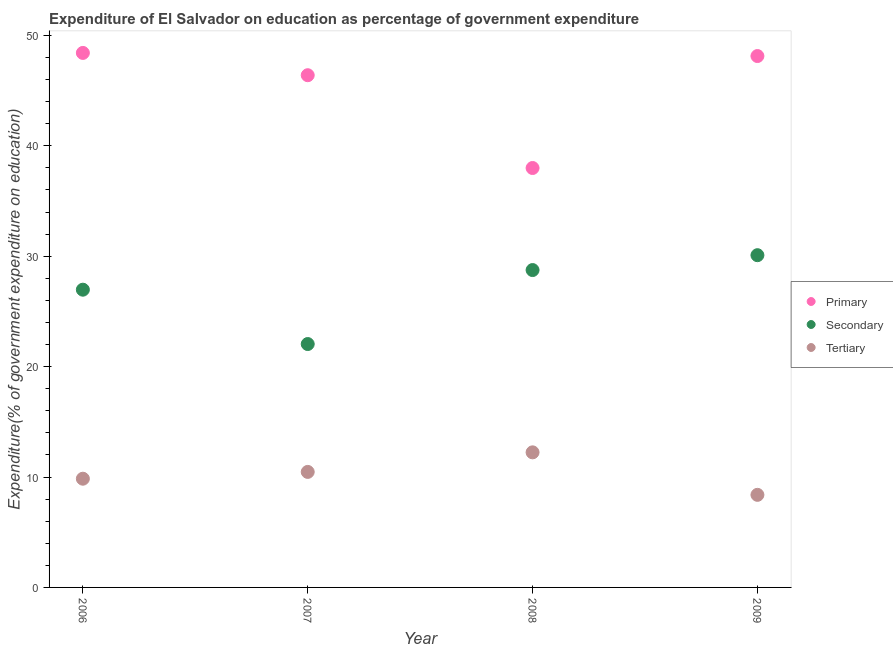How many different coloured dotlines are there?
Offer a very short reply. 3. Is the number of dotlines equal to the number of legend labels?
Your answer should be compact. Yes. What is the expenditure on primary education in 2008?
Offer a terse response. 37.99. Across all years, what is the maximum expenditure on tertiary education?
Ensure brevity in your answer.  12.24. Across all years, what is the minimum expenditure on tertiary education?
Offer a very short reply. 8.39. In which year was the expenditure on secondary education maximum?
Your answer should be compact. 2009. What is the total expenditure on secondary education in the graph?
Your response must be concise. 107.86. What is the difference between the expenditure on primary education in 2008 and that in 2009?
Provide a short and direct response. -10.14. What is the difference between the expenditure on secondary education in 2007 and the expenditure on tertiary education in 2008?
Offer a very short reply. 9.81. What is the average expenditure on tertiary education per year?
Give a very brief answer. 10.23. In the year 2007, what is the difference between the expenditure on tertiary education and expenditure on secondary education?
Keep it short and to the point. -11.58. In how many years, is the expenditure on tertiary education greater than 38 %?
Give a very brief answer. 0. What is the ratio of the expenditure on secondary education in 2007 to that in 2008?
Your answer should be very brief. 0.77. Is the expenditure on primary education in 2007 less than that in 2009?
Your response must be concise. Yes. Is the difference between the expenditure on tertiary education in 2007 and 2009 greater than the difference between the expenditure on primary education in 2007 and 2009?
Keep it short and to the point. Yes. What is the difference between the highest and the second highest expenditure on secondary education?
Provide a succinct answer. 1.35. What is the difference between the highest and the lowest expenditure on secondary education?
Ensure brevity in your answer.  8.05. In how many years, is the expenditure on tertiary education greater than the average expenditure on tertiary education taken over all years?
Your answer should be compact. 2. Is the expenditure on tertiary education strictly greater than the expenditure on primary education over the years?
Keep it short and to the point. No. Is the expenditure on tertiary education strictly less than the expenditure on secondary education over the years?
Keep it short and to the point. Yes. What is the difference between two consecutive major ticks on the Y-axis?
Your answer should be compact. 10. Does the graph contain grids?
Give a very brief answer. No. How many legend labels are there?
Your answer should be very brief. 3. How are the legend labels stacked?
Your answer should be compact. Vertical. What is the title of the graph?
Make the answer very short. Expenditure of El Salvador on education as percentage of government expenditure. What is the label or title of the X-axis?
Your answer should be very brief. Year. What is the label or title of the Y-axis?
Make the answer very short. Expenditure(% of government expenditure on education). What is the Expenditure(% of government expenditure on education) in Primary in 2006?
Your answer should be very brief. 48.42. What is the Expenditure(% of government expenditure on education) of Secondary in 2006?
Keep it short and to the point. 26.97. What is the Expenditure(% of government expenditure on education) in Tertiary in 2006?
Ensure brevity in your answer.  9.85. What is the Expenditure(% of government expenditure on education) of Primary in 2007?
Offer a terse response. 46.4. What is the Expenditure(% of government expenditure on education) of Secondary in 2007?
Provide a succinct answer. 22.05. What is the Expenditure(% of government expenditure on education) in Tertiary in 2007?
Your response must be concise. 10.46. What is the Expenditure(% of government expenditure on education) of Primary in 2008?
Provide a short and direct response. 37.99. What is the Expenditure(% of government expenditure on education) of Secondary in 2008?
Give a very brief answer. 28.75. What is the Expenditure(% of government expenditure on education) of Tertiary in 2008?
Your answer should be compact. 12.24. What is the Expenditure(% of government expenditure on education) in Primary in 2009?
Provide a short and direct response. 48.13. What is the Expenditure(% of government expenditure on education) in Secondary in 2009?
Provide a succinct answer. 30.09. What is the Expenditure(% of government expenditure on education) of Tertiary in 2009?
Ensure brevity in your answer.  8.39. Across all years, what is the maximum Expenditure(% of government expenditure on education) of Primary?
Give a very brief answer. 48.42. Across all years, what is the maximum Expenditure(% of government expenditure on education) in Secondary?
Offer a terse response. 30.09. Across all years, what is the maximum Expenditure(% of government expenditure on education) in Tertiary?
Your response must be concise. 12.24. Across all years, what is the minimum Expenditure(% of government expenditure on education) in Primary?
Keep it short and to the point. 37.99. Across all years, what is the minimum Expenditure(% of government expenditure on education) of Secondary?
Your answer should be compact. 22.05. Across all years, what is the minimum Expenditure(% of government expenditure on education) in Tertiary?
Keep it short and to the point. 8.39. What is the total Expenditure(% of government expenditure on education) of Primary in the graph?
Provide a succinct answer. 180.94. What is the total Expenditure(% of government expenditure on education) of Secondary in the graph?
Give a very brief answer. 107.86. What is the total Expenditure(% of government expenditure on education) in Tertiary in the graph?
Offer a terse response. 40.93. What is the difference between the Expenditure(% of government expenditure on education) in Primary in 2006 and that in 2007?
Offer a terse response. 2.02. What is the difference between the Expenditure(% of government expenditure on education) in Secondary in 2006 and that in 2007?
Provide a short and direct response. 4.92. What is the difference between the Expenditure(% of government expenditure on education) of Tertiary in 2006 and that in 2007?
Keep it short and to the point. -0.62. What is the difference between the Expenditure(% of government expenditure on education) in Primary in 2006 and that in 2008?
Offer a very short reply. 10.42. What is the difference between the Expenditure(% of government expenditure on education) of Secondary in 2006 and that in 2008?
Your answer should be compact. -1.78. What is the difference between the Expenditure(% of government expenditure on education) of Tertiary in 2006 and that in 2008?
Provide a succinct answer. -2.39. What is the difference between the Expenditure(% of government expenditure on education) in Primary in 2006 and that in 2009?
Offer a terse response. 0.28. What is the difference between the Expenditure(% of government expenditure on education) of Secondary in 2006 and that in 2009?
Your response must be concise. -3.13. What is the difference between the Expenditure(% of government expenditure on education) of Tertiary in 2006 and that in 2009?
Ensure brevity in your answer.  1.46. What is the difference between the Expenditure(% of government expenditure on education) in Primary in 2007 and that in 2008?
Your response must be concise. 8.41. What is the difference between the Expenditure(% of government expenditure on education) in Secondary in 2007 and that in 2008?
Your response must be concise. -6.7. What is the difference between the Expenditure(% of government expenditure on education) in Tertiary in 2007 and that in 2008?
Make the answer very short. -1.77. What is the difference between the Expenditure(% of government expenditure on education) in Primary in 2007 and that in 2009?
Your answer should be very brief. -1.74. What is the difference between the Expenditure(% of government expenditure on education) of Secondary in 2007 and that in 2009?
Make the answer very short. -8.05. What is the difference between the Expenditure(% of government expenditure on education) of Tertiary in 2007 and that in 2009?
Your answer should be compact. 2.08. What is the difference between the Expenditure(% of government expenditure on education) in Primary in 2008 and that in 2009?
Offer a terse response. -10.14. What is the difference between the Expenditure(% of government expenditure on education) of Secondary in 2008 and that in 2009?
Keep it short and to the point. -1.35. What is the difference between the Expenditure(% of government expenditure on education) in Tertiary in 2008 and that in 2009?
Provide a short and direct response. 3.85. What is the difference between the Expenditure(% of government expenditure on education) of Primary in 2006 and the Expenditure(% of government expenditure on education) of Secondary in 2007?
Offer a very short reply. 26.37. What is the difference between the Expenditure(% of government expenditure on education) in Primary in 2006 and the Expenditure(% of government expenditure on education) in Tertiary in 2007?
Give a very brief answer. 37.95. What is the difference between the Expenditure(% of government expenditure on education) in Secondary in 2006 and the Expenditure(% of government expenditure on education) in Tertiary in 2007?
Provide a short and direct response. 16.51. What is the difference between the Expenditure(% of government expenditure on education) in Primary in 2006 and the Expenditure(% of government expenditure on education) in Secondary in 2008?
Your response must be concise. 19.67. What is the difference between the Expenditure(% of government expenditure on education) of Primary in 2006 and the Expenditure(% of government expenditure on education) of Tertiary in 2008?
Offer a very short reply. 36.18. What is the difference between the Expenditure(% of government expenditure on education) of Secondary in 2006 and the Expenditure(% of government expenditure on education) of Tertiary in 2008?
Provide a short and direct response. 14.73. What is the difference between the Expenditure(% of government expenditure on education) of Primary in 2006 and the Expenditure(% of government expenditure on education) of Secondary in 2009?
Keep it short and to the point. 18.32. What is the difference between the Expenditure(% of government expenditure on education) in Primary in 2006 and the Expenditure(% of government expenditure on education) in Tertiary in 2009?
Your response must be concise. 40.03. What is the difference between the Expenditure(% of government expenditure on education) in Secondary in 2006 and the Expenditure(% of government expenditure on education) in Tertiary in 2009?
Offer a very short reply. 18.58. What is the difference between the Expenditure(% of government expenditure on education) in Primary in 2007 and the Expenditure(% of government expenditure on education) in Secondary in 2008?
Make the answer very short. 17.65. What is the difference between the Expenditure(% of government expenditure on education) of Primary in 2007 and the Expenditure(% of government expenditure on education) of Tertiary in 2008?
Provide a short and direct response. 34.16. What is the difference between the Expenditure(% of government expenditure on education) of Secondary in 2007 and the Expenditure(% of government expenditure on education) of Tertiary in 2008?
Your answer should be very brief. 9.81. What is the difference between the Expenditure(% of government expenditure on education) of Primary in 2007 and the Expenditure(% of government expenditure on education) of Secondary in 2009?
Give a very brief answer. 16.3. What is the difference between the Expenditure(% of government expenditure on education) in Primary in 2007 and the Expenditure(% of government expenditure on education) in Tertiary in 2009?
Give a very brief answer. 38.01. What is the difference between the Expenditure(% of government expenditure on education) in Secondary in 2007 and the Expenditure(% of government expenditure on education) in Tertiary in 2009?
Ensure brevity in your answer.  13.66. What is the difference between the Expenditure(% of government expenditure on education) in Primary in 2008 and the Expenditure(% of government expenditure on education) in Secondary in 2009?
Your response must be concise. 7.9. What is the difference between the Expenditure(% of government expenditure on education) of Primary in 2008 and the Expenditure(% of government expenditure on education) of Tertiary in 2009?
Your response must be concise. 29.61. What is the difference between the Expenditure(% of government expenditure on education) in Secondary in 2008 and the Expenditure(% of government expenditure on education) in Tertiary in 2009?
Provide a succinct answer. 20.36. What is the average Expenditure(% of government expenditure on education) in Primary per year?
Ensure brevity in your answer.  45.23. What is the average Expenditure(% of government expenditure on education) of Secondary per year?
Provide a short and direct response. 26.96. What is the average Expenditure(% of government expenditure on education) in Tertiary per year?
Provide a succinct answer. 10.23. In the year 2006, what is the difference between the Expenditure(% of government expenditure on education) of Primary and Expenditure(% of government expenditure on education) of Secondary?
Offer a terse response. 21.45. In the year 2006, what is the difference between the Expenditure(% of government expenditure on education) of Primary and Expenditure(% of government expenditure on education) of Tertiary?
Provide a short and direct response. 38.57. In the year 2006, what is the difference between the Expenditure(% of government expenditure on education) in Secondary and Expenditure(% of government expenditure on education) in Tertiary?
Your response must be concise. 17.12. In the year 2007, what is the difference between the Expenditure(% of government expenditure on education) in Primary and Expenditure(% of government expenditure on education) in Secondary?
Your answer should be compact. 24.35. In the year 2007, what is the difference between the Expenditure(% of government expenditure on education) of Primary and Expenditure(% of government expenditure on education) of Tertiary?
Make the answer very short. 35.93. In the year 2007, what is the difference between the Expenditure(% of government expenditure on education) in Secondary and Expenditure(% of government expenditure on education) in Tertiary?
Keep it short and to the point. 11.58. In the year 2008, what is the difference between the Expenditure(% of government expenditure on education) of Primary and Expenditure(% of government expenditure on education) of Secondary?
Offer a very short reply. 9.24. In the year 2008, what is the difference between the Expenditure(% of government expenditure on education) in Primary and Expenditure(% of government expenditure on education) in Tertiary?
Make the answer very short. 25.76. In the year 2008, what is the difference between the Expenditure(% of government expenditure on education) in Secondary and Expenditure(% of government expenditure on education) in Tertiary?
Your answer should be compact. 16.51. In the year 2009, what is the difference between the Expenditure(% of government expenditure on education) of Primary and Expenditure(% of government expenditure on education) of Secondary?
Ensure brevity in your answer.  18.04. In the year 2009, what is the difference between the Expenditure(% of government expenditure on education) of Primary and Expenditure(% of government expenditure on education) of Tertiary?
Offer a very short reply. 39.75. In the year 2009, what is the difference between the Expenditure(% of government expenditure on education) of Secondary and Expenditure(% of government expenditure on education) of Tertiary?
Provide a short and direct response. 21.71. What is the ratio of the Expenditure(% of government expenditure on education) in Primary in 2006 to that in 2007?
Offer a terse response. 1.04. What is the ratio of the Expenditure(% of government expenditure on education) in Secondary in 2006 to that in 2007?
Make the answer very short. 1.22. What is the ratio of the Expenditure(% of government expenditure on education) in Tertiary in 2006 to that in 2007?
Make the answer very short. 0.94. What is the ratio of the Expenditure(% of government expenditure on education) in Primary in 2006 to that in 2008?
Make the answer very short. 1.27. What is the ratio of the Expenditure(% of government expenditure on education) of Secondary in 2006 to that in 2008?
Your answer should be very brief. 0.94. What is the ratio of the Expenditure(% of government expenditure on education) in Tertiary in 2006 to that in 2008?
Provide a succinct answer. 0.8. What is the ratio of the Expenditure(% of government expenditure on education) of Primary in 2006 to that in 2009?
Give a very brief answer. 1.01. What is the ratio of the Expenditure(% of government expenditure on education) of Secondary in 2006 to that in 2009?
Provide a succinct answer. 0.9. What is the ratio of the Expenditure(% of government expenditure on education) in Tertiary in 2006 to that in 2009?
Keep it short and to the point. 1.17. What is the ratio of the Expenditure(% of government expenditure on education) in Primary in 2007 to that in 2008?
Give a very brief answer. 1.22. What is the ratio of the Expenditure(% of government expenditure on education) of Secondary in 2007 to that in 2008?
Offer a very short reply. 0.77. What is the ratio of the Expenditure(% of government expenditure on education) of Tertiary in 2007 to that in 2008?
Your answer should be very brief. 0.86. What is the ratio of the Expenditure(% of government expenditure on education) of Primary in 2007 to that in 2009?
Keep it short and to the point. 0.96. What is the ratio of the Expenditure(% of government expenditure on education) in Secondary in 2007 to that in 2009?
Ensure brevity in your answer.  0.73. What is the ratio of the Expenditure(% of government expenditure on education) of Tertiary in 2007 to that in 2009?
Provide a succinct answer. 1.25. What is the ratio of the Expenditure(% of government expenditure on education) in Primary in 2008 to that in 2009?
Your answer should be very brief. 0.79. What is the ratio of the Expenditure(% of government expenditure on education) in Secondary in 2008 to that in 2009?
Offer a terse response. 0.96. What is the ratio of the Expenditure(% of government expenditure on education) in Tertiary in 2008 to that in 2009?
Keep it short and to the point. 1.46. What is the difference between the highest and the second highest Expenditure(% of government expenditure on education) in Primary?
Keep it short and to the point. 0.28. What is the difference between the highest and the second highest Expenditure(% of government expenditure on education) of Secondary?
Offer a very short reply. 1.35. What is the difference between the highest and the second highest Expenditure(% of government expenditure on education) of Tertiary?
Make the answer very short. 1.77. What is the difference between the highest and the lowest Expenditure(% of government expenditure on education) in Primary?
Provide a succinct answer. 10.42. What is the difference between the highest and the lowest Expenditure(% of government expenditure on education) of Secondary?
Offer a very short reply. 8.05. What is the difference between the highest and the lowest Expenditure(% of government expenditure on education) in Tertiary?
Make the answer very short. 3.85. 